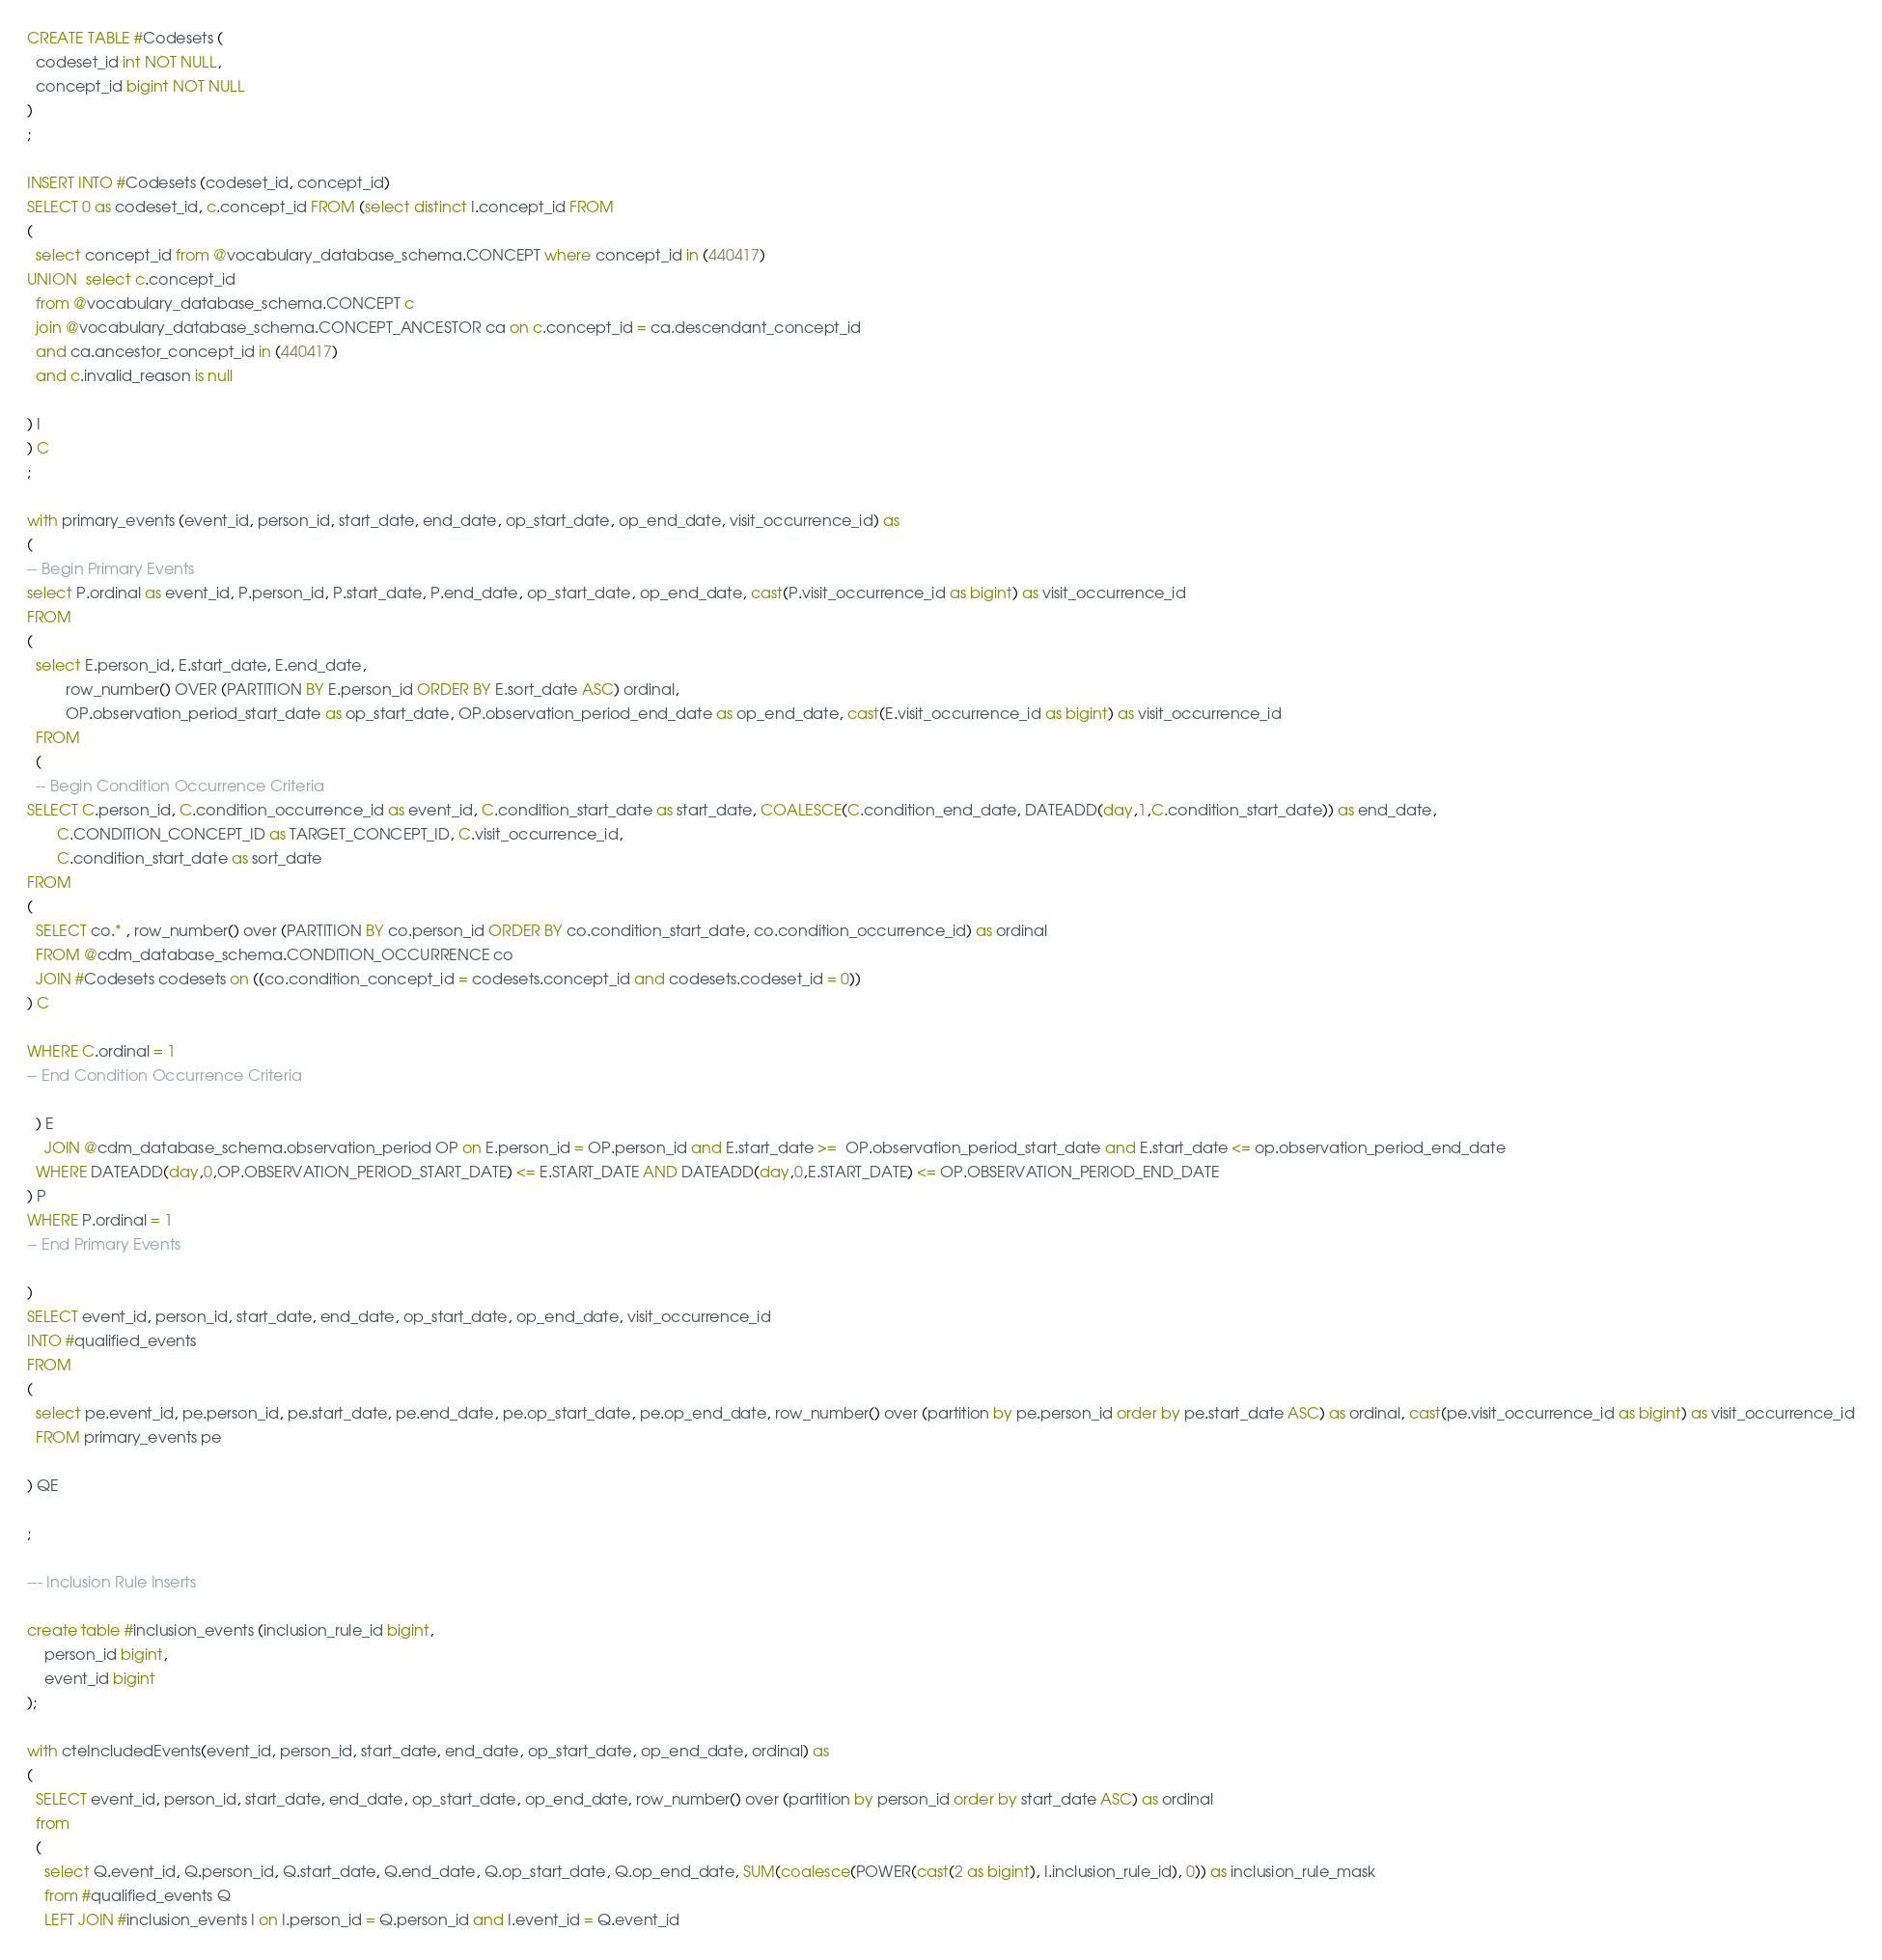<code> <loc_0><loc_0><loc_500><loc_500><_SQL_>CREATE TABLE #Codesets (
  codeset_id int NOT NULL,
  concept_id bigint NOT NULL
)
;

INSERT INTO #Codesets (codeset_id, concept_id)
SELECT 0 as codeset_id, c.concept_id FROM (select distinct I.concept_id FROM
( 
  select concept_id from @vocabulary_database_schema.CONCEPT where concept_id in (440417)
UNION  select c.concept_id
  from @vocabulary_database_schema.CONCEPT c
  join @vocabulary_database_schema.CONCEPT_ANCESTOR ca on c.concept_id = ca.descendant_concept_id
  and ca.ancestor_concept_id in (440417)
  and c.invalid_reason is null

) I
) C
;

with primary_events (event_id, person_id, start_date, end_date, op_start_date, op_end_date, visit_occurrence_id) as
(
-- Begin Primary Events
select P.ordinal as event_id, P.person_id, P.start_date, P.end_date, op_start_date, op_end_date, cast(P.visit_occurrence_id as bigint) as visit_occurrence_id
FROM
(
  select E.person_id, E.start_date, E.end_date,
         row_number() OVER (PARTITION BY E.person_id ORDER BY E.sort_date ASC) ordinal,
         OP.observation_period_start_date as op_start_date, OP.observation_period_end_date as op_end_date, cast(E.visit_occurrence_id as bigint) as visit_occurrence_id
  FROM 
  (
  -- Begin Condition Occurrence Criteria
SELECT C.person_id, C.condition_occurrence_id as event_id, C.condition_start_date as start_date, COALESCE(C.condition_end_date, DATEADD(day,1,C.condition_start_date)) as end_date,
       C.CONDITION_CONCEPT_ID as TARGET_CONCEPT_ID, C.visit_occurrence_id,
       C.condition_start_date as sort_date
FROM 
(
  SELECT co.* , row_number() over (PARTITION BY co.person_id ORDER BY co.condition_start_date, co.condition_occurrence_id) as ordinal
  FROM @cdm_database_schema.CONDITION_OCCURRENCE co
  JOIN #Codesets codesets on ((co.condition_concept_id = codesets.concept_id and codesets.codeset_id = 0))
) C

WHERE C.ordinal = 1
-- End Condition Occurrence Criteria

  ) E
	JOIN @cdm_database_schema.observation_period OP on E.person_id = OP.person_id and E.start_date >=  OP.observation_period_start_date and E.start_date <= op.observation_period_end_date
  WHERE DATEADD(day,0,OP.OBSERVATION_PERIOD_START_DATE) <= E.START_DATE AND DATEADD(day,0,E.START_DATE) <= OP.OBSERVATION_PERIOD_END_DATE
) P
WHERE P.ordinal = 1
-- End Primary Events

)
SELECT event_id, person_id, start_date, end_date, op_start_date, op_end_date, visit_occurrence_id
INTO #qualified_events
FROM 
(
  select pe.event_id, pe.person_id, pe.start_date, pe.end_date, pe.op_start_date, pe.op_end_date, row_number() over (partition by pe.person_id order by pe.start_date ASC) as ordinal, cast(pe.visit_occurrence_id as bigint) as visit_occurrence_id
  FROM primary_events pe
  
) QE

;

--- Inclusion Rule Inserts

create table #inclusion_events (inclusion_rule_id bigint,
	person_id bigint,
	event_id bigint
);

with cteIncludedEvents(event_id, person_id, start_date, end_date, op_start_date, op_end_date, ordinal) as
(
  SELECT event_id, person_id, start_date, end_date, op_start_date, op_end_date, row_number() over (partition by person_id order by start_date ASC) as ordinal
  from
  (
    select Q.event_id, Q.person_id, Q.start_date, Q.end_date, Q.op_start_date, Q.op_end_date, SUM(coalesce(POWER(cast(2 as bigint), I.inclusion_rule_id), 0)) as inclusion_rule_mask
    from #qualified_events Q
    LEFT JOIN #inclusion_events I on I.person_id = Q.person_id and I.event_id = Q.event_id</code> 